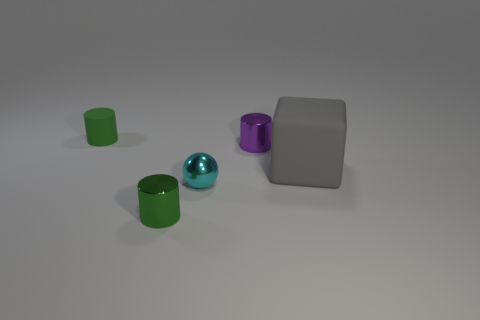Does the cyan shiny thing have the same shape as the big object?
Provide a short and direct response. No. How many tiny cyan balls are in front of the green cylinder behind the large thing?
Make the answer very short. 1. What is the shape of the green object that is the same material as the cyan sphere?
Your response must be concise. Cylinder. What number of cyan things are either tiny balls or big cubes?
Ensure brevity in your answer.  1. There is a small cylinder that is in front of the big matte thing that is right of the purple metal object; are there any gray matte blocks that are on the left side of it?
Your answer should be very brief. No. Is the number of tiny purple cylinders less than the number of tiny red metal cubes?
Offer a very short reply. No. There is a thing that is right of the tiny purple object; does it have the same shape as the small green matte object?
Make the answer very short. No. Are there any small shiny spheres?
Keep it short and to the point. Yes. There is a metal object that is behind the matte thing that is in front of the small metallic cylinder that is behind the cyan metal object; what is its color?
Your answer should be compact. Purple. Is the number of small metallic balls behind the cube the same as the number of green metal cylinders in front of the cyan object?
Your answer should be compact. No. 